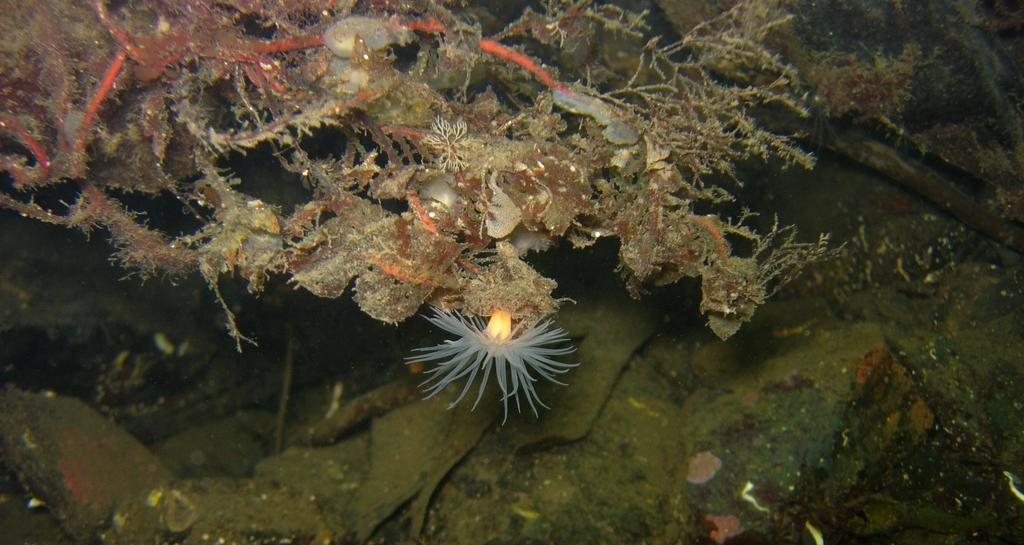What type of environment is depicted in the image? The image is an underwater scene. What types of plants can be seen in the underwater environment? There are aquatic plants in the image, which have various colors, including green, orange, cream, and yellow. Are there any other objects present in the underwater scene? Yes, there are other objects present in the underwater scene, but their specific details are not mentioned in the provided facts. What is the duration of the recess in the image? There is no reference to a recess or any time-related information in the image, as it is an underwater scene with aquatic plants and other objects. 